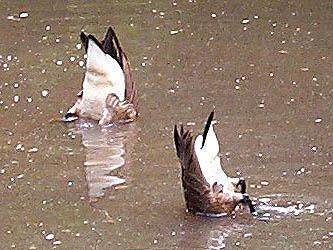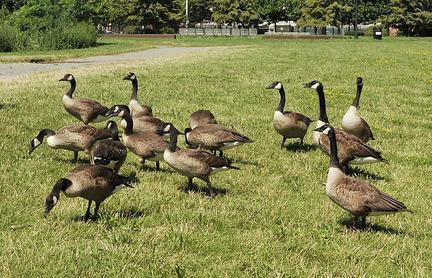The first image is the image on the left, the second image is the image on the right. Considering the images on both sides, is "In one of the image the geese are in the water." valid? Answer yes or no. Yes. The first image is the image on the left, the second image is the image on the right. Given the left and right images, does the statement "There is a single black and gray goose grazing in the grass." hold true? Answer yes or no. No. 